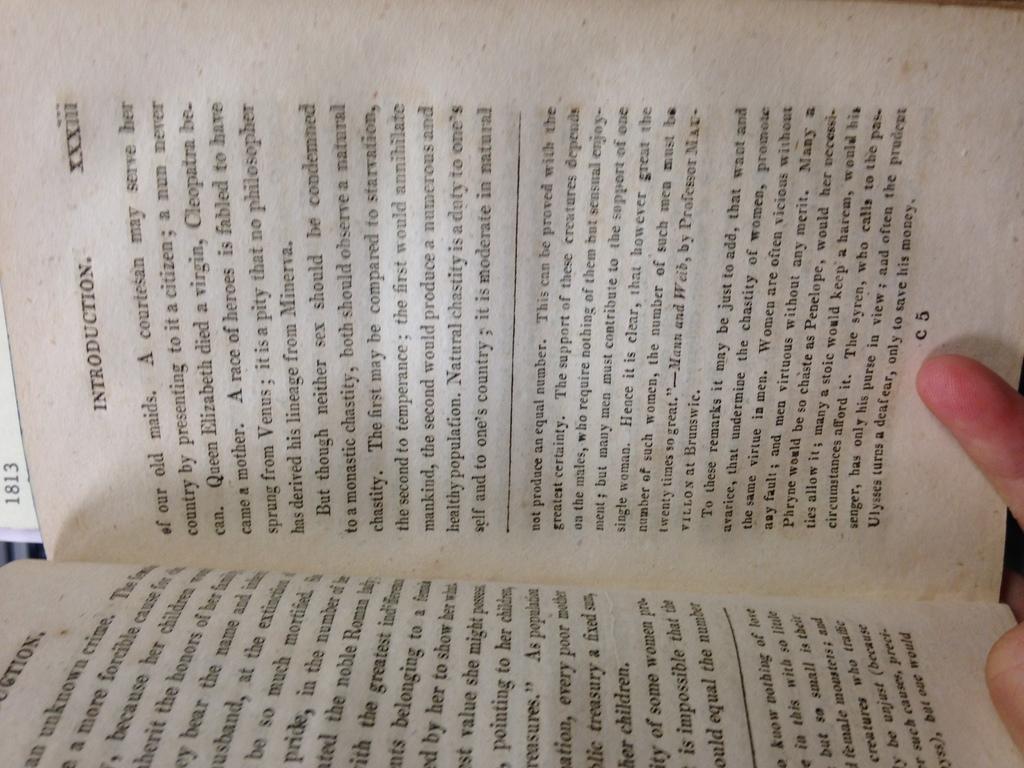What type of chapter is this?
Keep it short and to the point. Introduction. What number is the chapter?
Your answer should be compact. Xxxiii. 